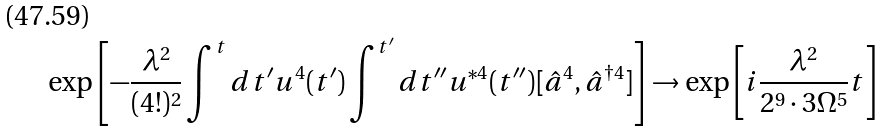<formula> <loc_0><loc_0><loc_500><loc_500>\exp \left [ - \frac { \lambda ^ { 2 } } { ( 4 ! ) ^ { 2 } } \int ^ { t } d t ^ { \prime } u ^ { 4 } ( t ^ { \prime } ) \int ^ { t ^ { \prime } } d t ^ { \prime \prime } u ^ { * 4 } ( t ^ { \prime \prime } ) [ \hat { a } ^ { 4 } , \hat { a } ^ { \dagger 4 } ] \right ] \rightarrow \exp \left [ i \frac { \lambda ^ { 2 } } { 2 ^ { 9 } \cdot 3 \Omega ^ { 5 } } t \right ]</formula> 